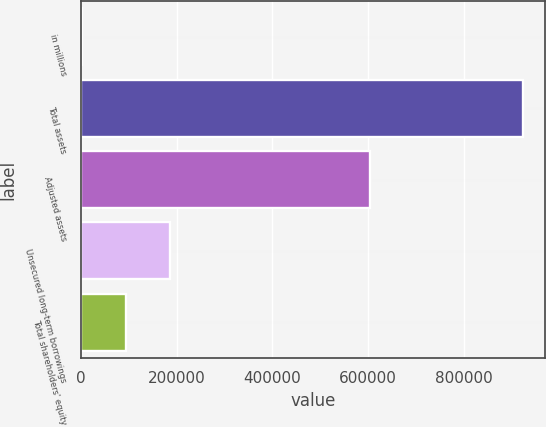Convert chart to OTSL. <chart><loc_0><loc_0><loc_500><loc_500><bar_chart><fcel>in millions<fcel>Total assets<fcel>Adjusted assets<fcel>Unsecured long-term borrowings<fcel>Total shareholders' equity<nl><fcel>2011<fcel>923225<fcel>604391<fcel>186254<fcel>94132.4<nl></chart> 